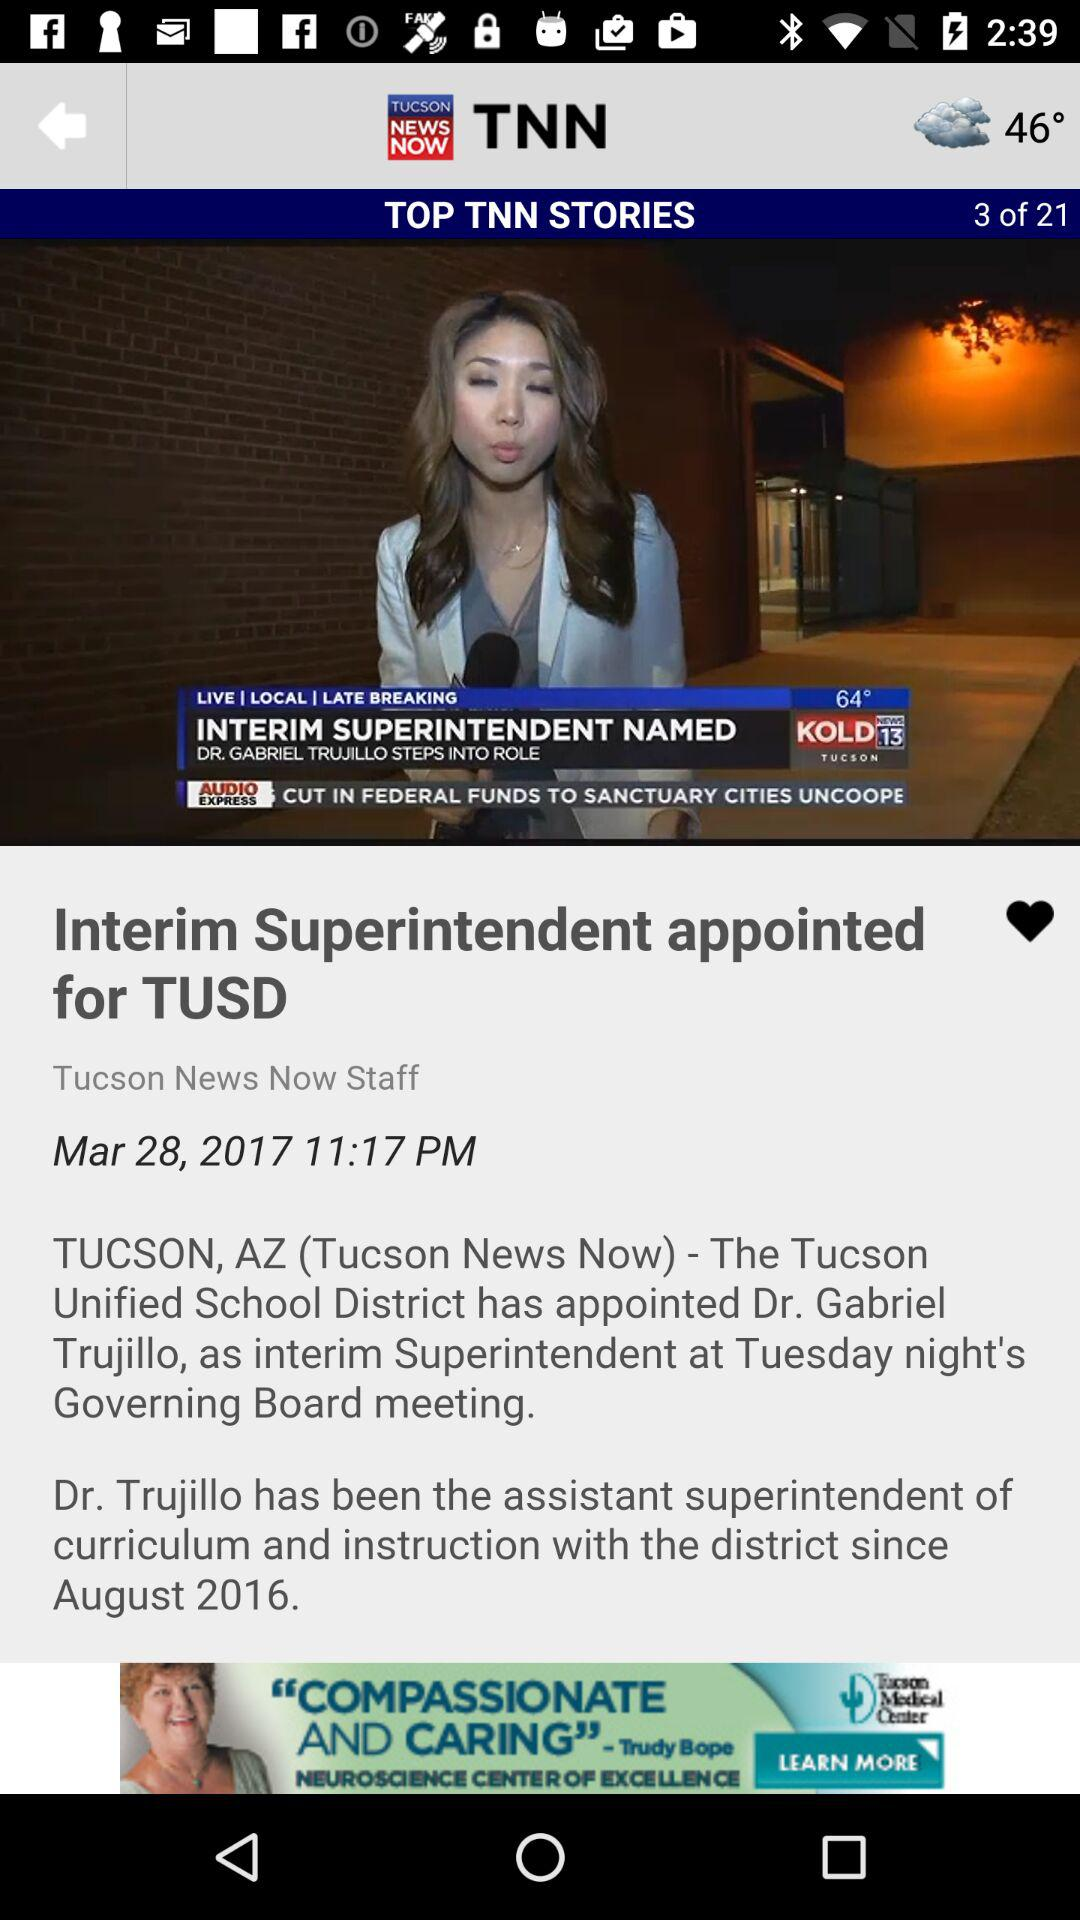What is the temperature? The temperatures are 46° and 64°. 